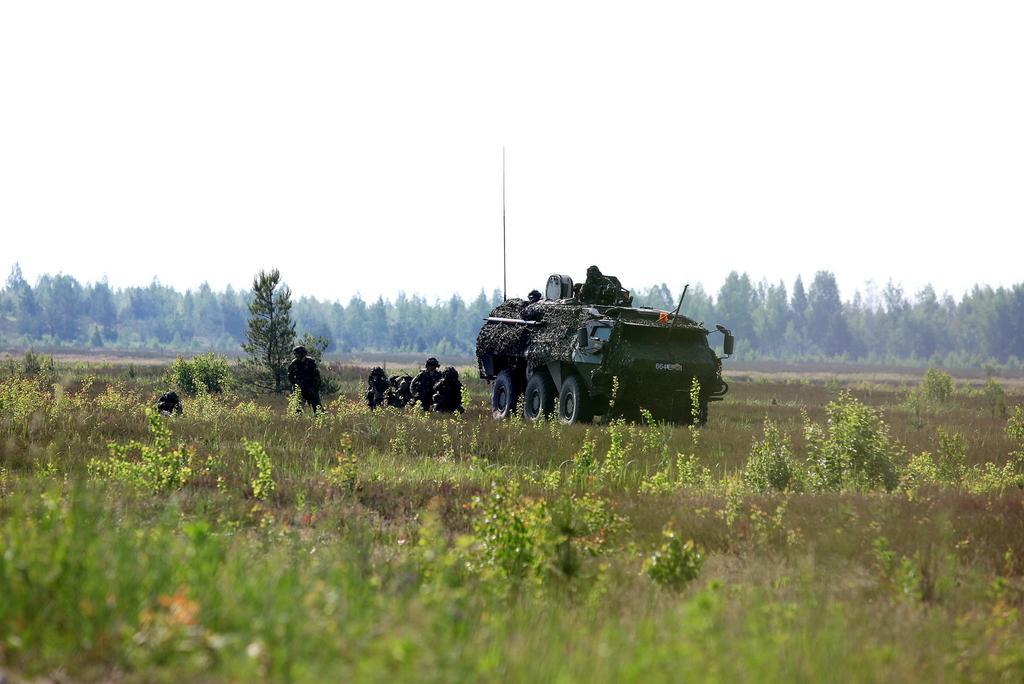Could you give a brief overview of what you see in this image? In this picture we can see a vehicle and some persons on the ground and in the background we can see trees, sky. 